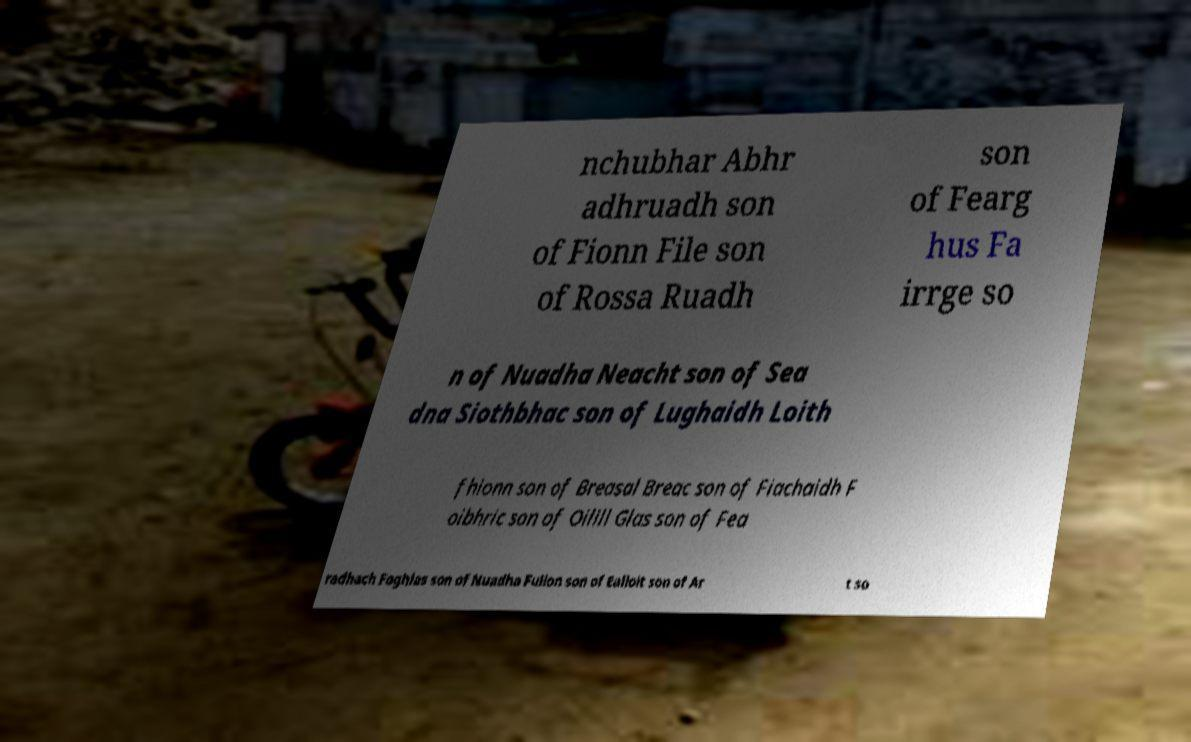Can you accurately transcribe the text from the provided image for me? nchubhar Abhr adhruadh son of Fionn File son of Rossa Ruadh son of Fearg hus Fa irrge so n of Nuadha Neacht son of Sea dna Siothbhac son of Lughaidh Loith fhionn son of Breasal Breac son of Fiachaidh F oibhric son of Oilill Glas son of Fea radhach Foghlas son of Nuadha Fullon son of Ealloit son of Ar t so 